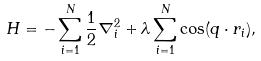<formula> <loc_0><loc_0><loc_500><loc_500>H = - \sum _ { i = 1 } ^ { N } \frac { 1 } { 2 } \nabla ^ { 2 } _ { i } + \lambda \sum _ { i = 1 } ^ { N } \cos ( { q } \cdot { r } _ { i } ) ,</formula> 